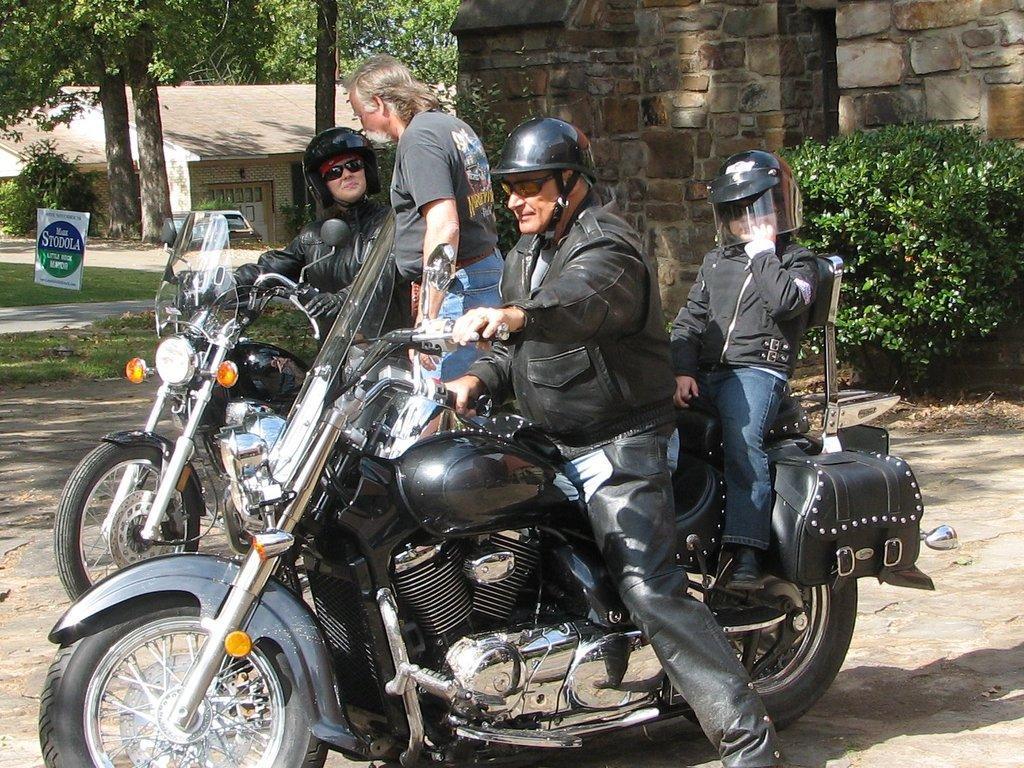In one or two sentences, can you explain what this image depicts? Here we can see four persons and there are two bikes. This is grass and there is a board. Here we can see planets, houses, and trees. 